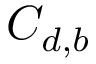<formula> <loc_0><loc_0><loc_500><loc_500>C _ { d , b }</formula> 